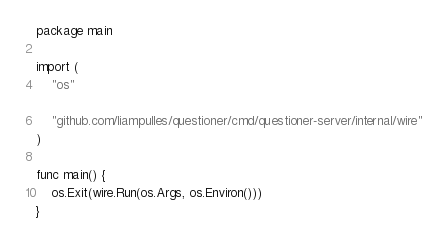<code> <loc_0><loc_0><loc_500><loc_500><_Go_>package main

import (
	"os"

	"github.com/liampulles/questioner/cmd/questioner-server/internal/wire"
)

func main() {
	os.Exit(wire.Run(os.Args, os.Environ()))
}
</code> 